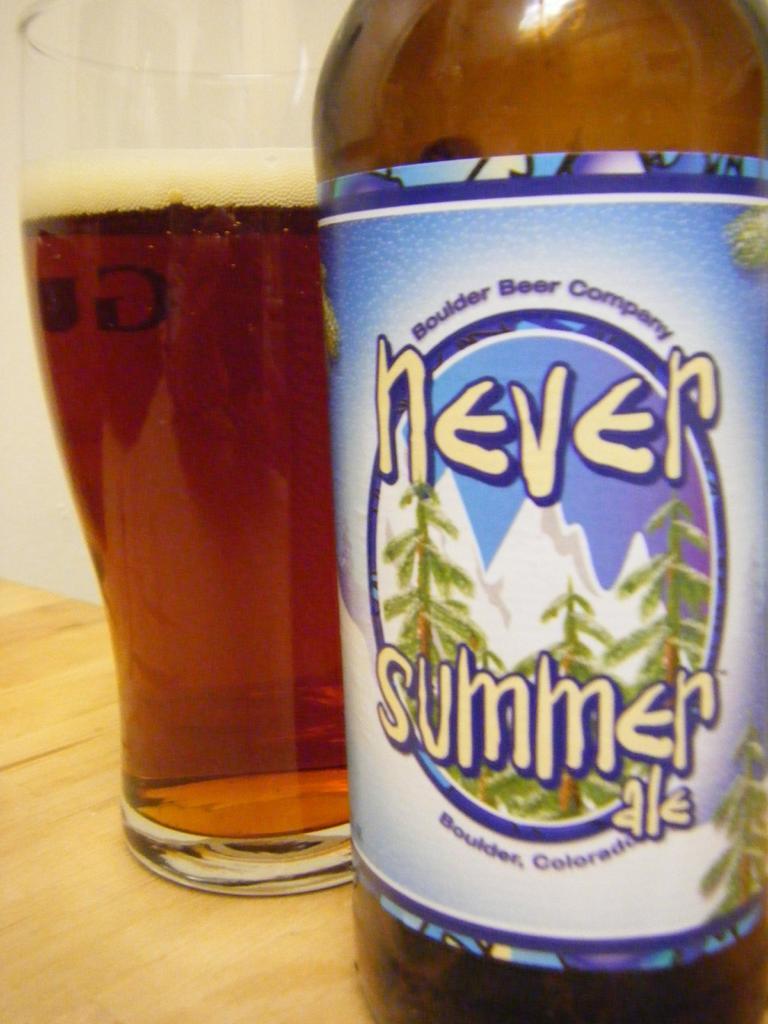What kind of drink is this?
Provide a succinct answer. Never summer ale. Where is this beer brewed?
Keep it short and to the point. Boulder, colorado. 